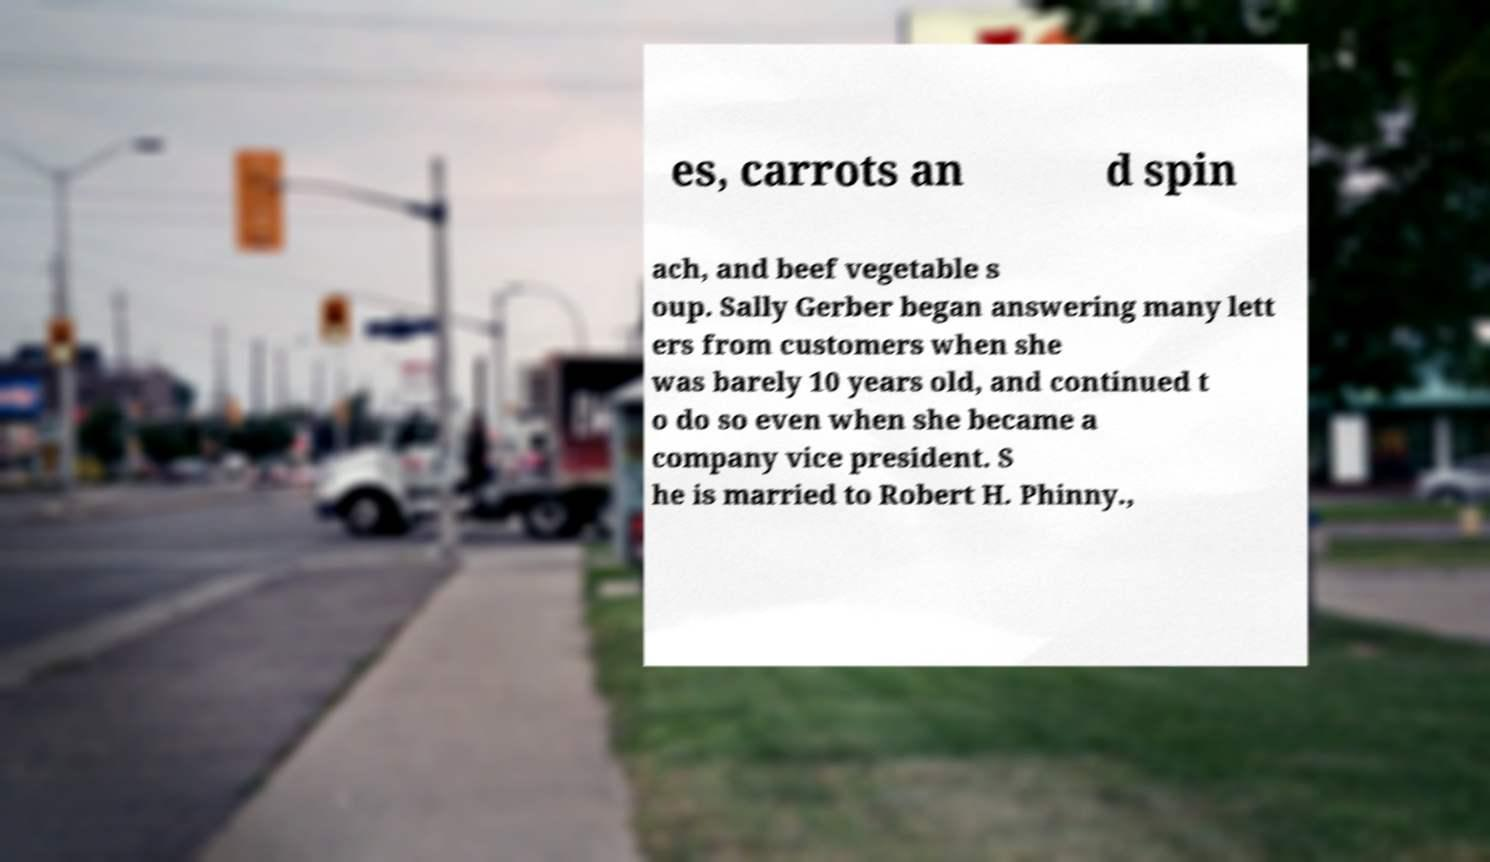Please identify and transcribe the text found in this image. es, carrots an d spin ach, and beef vegetable s oup. Sally Gerber began answering many lett ers from customers when she was barely 10 years old, and continued t o do so even when she became a company vice president. S he is married to Robert H. Phinny., 